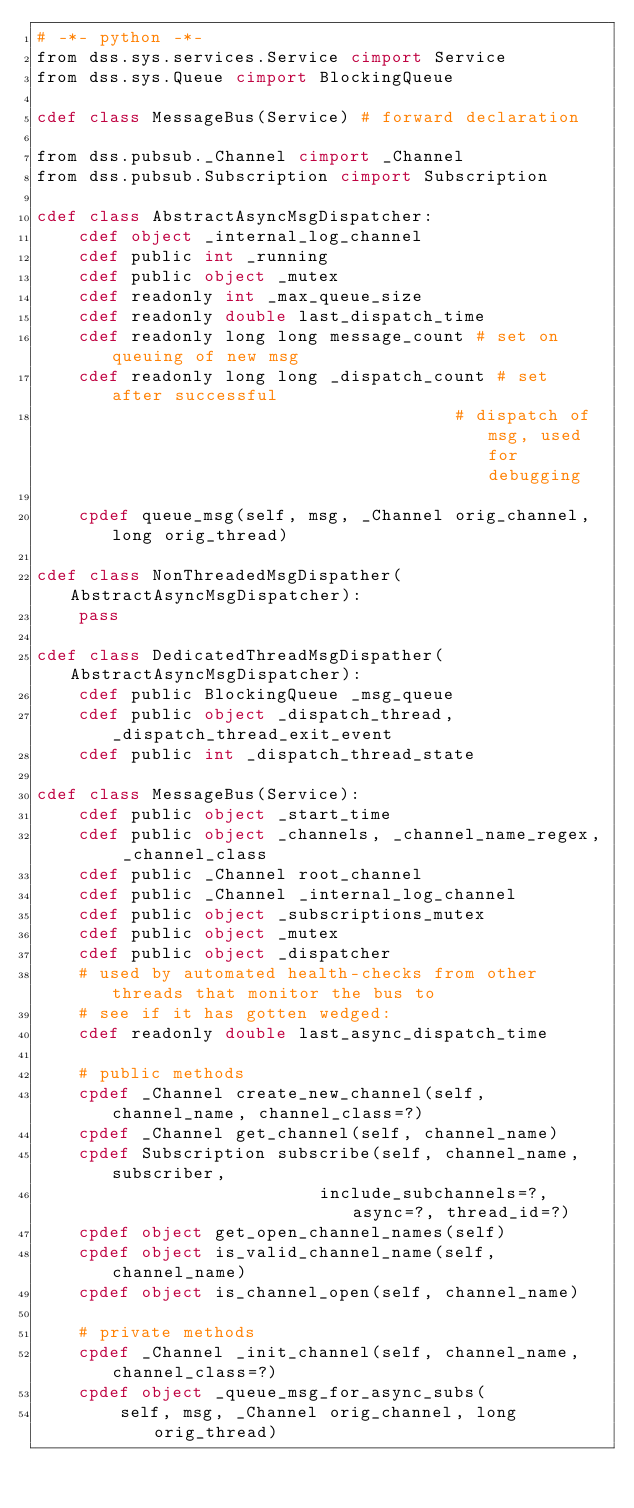<code> <loc_0><loc_0><loc_500><loc_500><_Cython_># -*- python -*-
from dss.sys.services.Service cimport Service
from dss.sys.Queue cimport BlockingQueue

cdef class MessageBus(Service) # forward declaration

from dss.pubsub._Channel cimport _Channel
from dss.pubsub.Subscription cimport Subscription

cdef class AbstractAsyncMsgDispatcher:
    cdef object _internal_log_channel
    cdef public int _running
    cdef public object _mutex
    cdef readonly int _max_queue_size
    cdef readonly double last_dispatch_time
    cdef readonly long long message_count # set on queuing of new msg
    cdef readonly long long _dispatch_count # set after successful
                                        # dispatch of msg, used for debugging

    cpdef queue_msg(self, msg, _Channel orig_channel, long orig_thread)

cdef class NonThreadedMsgDispather(AbstractAsyncMsgDispatcher):
    pass

cdef class DedicatedThreadMsgDispather(AbstractAsyncMsgDispatcher):
    cdef public BlockingQueue _msg_queue
    cdef public object _dispatch_thread, _dispatch_thread_exit_event
    cdef public int _dispatch_thread_state

cdef class MessageBus(Service):
    cdef public object _start_time
    cdef public object _channels, _channel_name_regex, _channel_class
    cdef public _Channel root_channel
    cdef public _Channel _internal_log_channel
    cdef public object _subscriptions_mutex
    cdef public object _mutex
    cdef public object _dispatcher
    # used by automated health-checks from other threads that monitor the bus to
    # see if it has gotten wedged:
    cdef readonly double last_async_dispatch_time

    # public methods
    cpdef _Channel create_new_channel(self, channel_name, channel_class=?)
    cpdef _Channel get_channel(self, channel_name)
    cpdef Subscription subscribe(self, channel_name, subscriber,
                           include_subchannels=?, async=?, thread_id=?)
    cpdef object get_open_channel_names(self)
    cpdef object is_valid_channel_name(self, channel_name)
    cpdef object is_channel_open(self, channel_name)

    # private methods
    cpdef _Channel _init_channel(self, channel_name, channel_class=?)
    cpdef object _queue_msg_for_async_subs(
        self, msg, _Channel orig_channel, long orig_thread)
</code> 